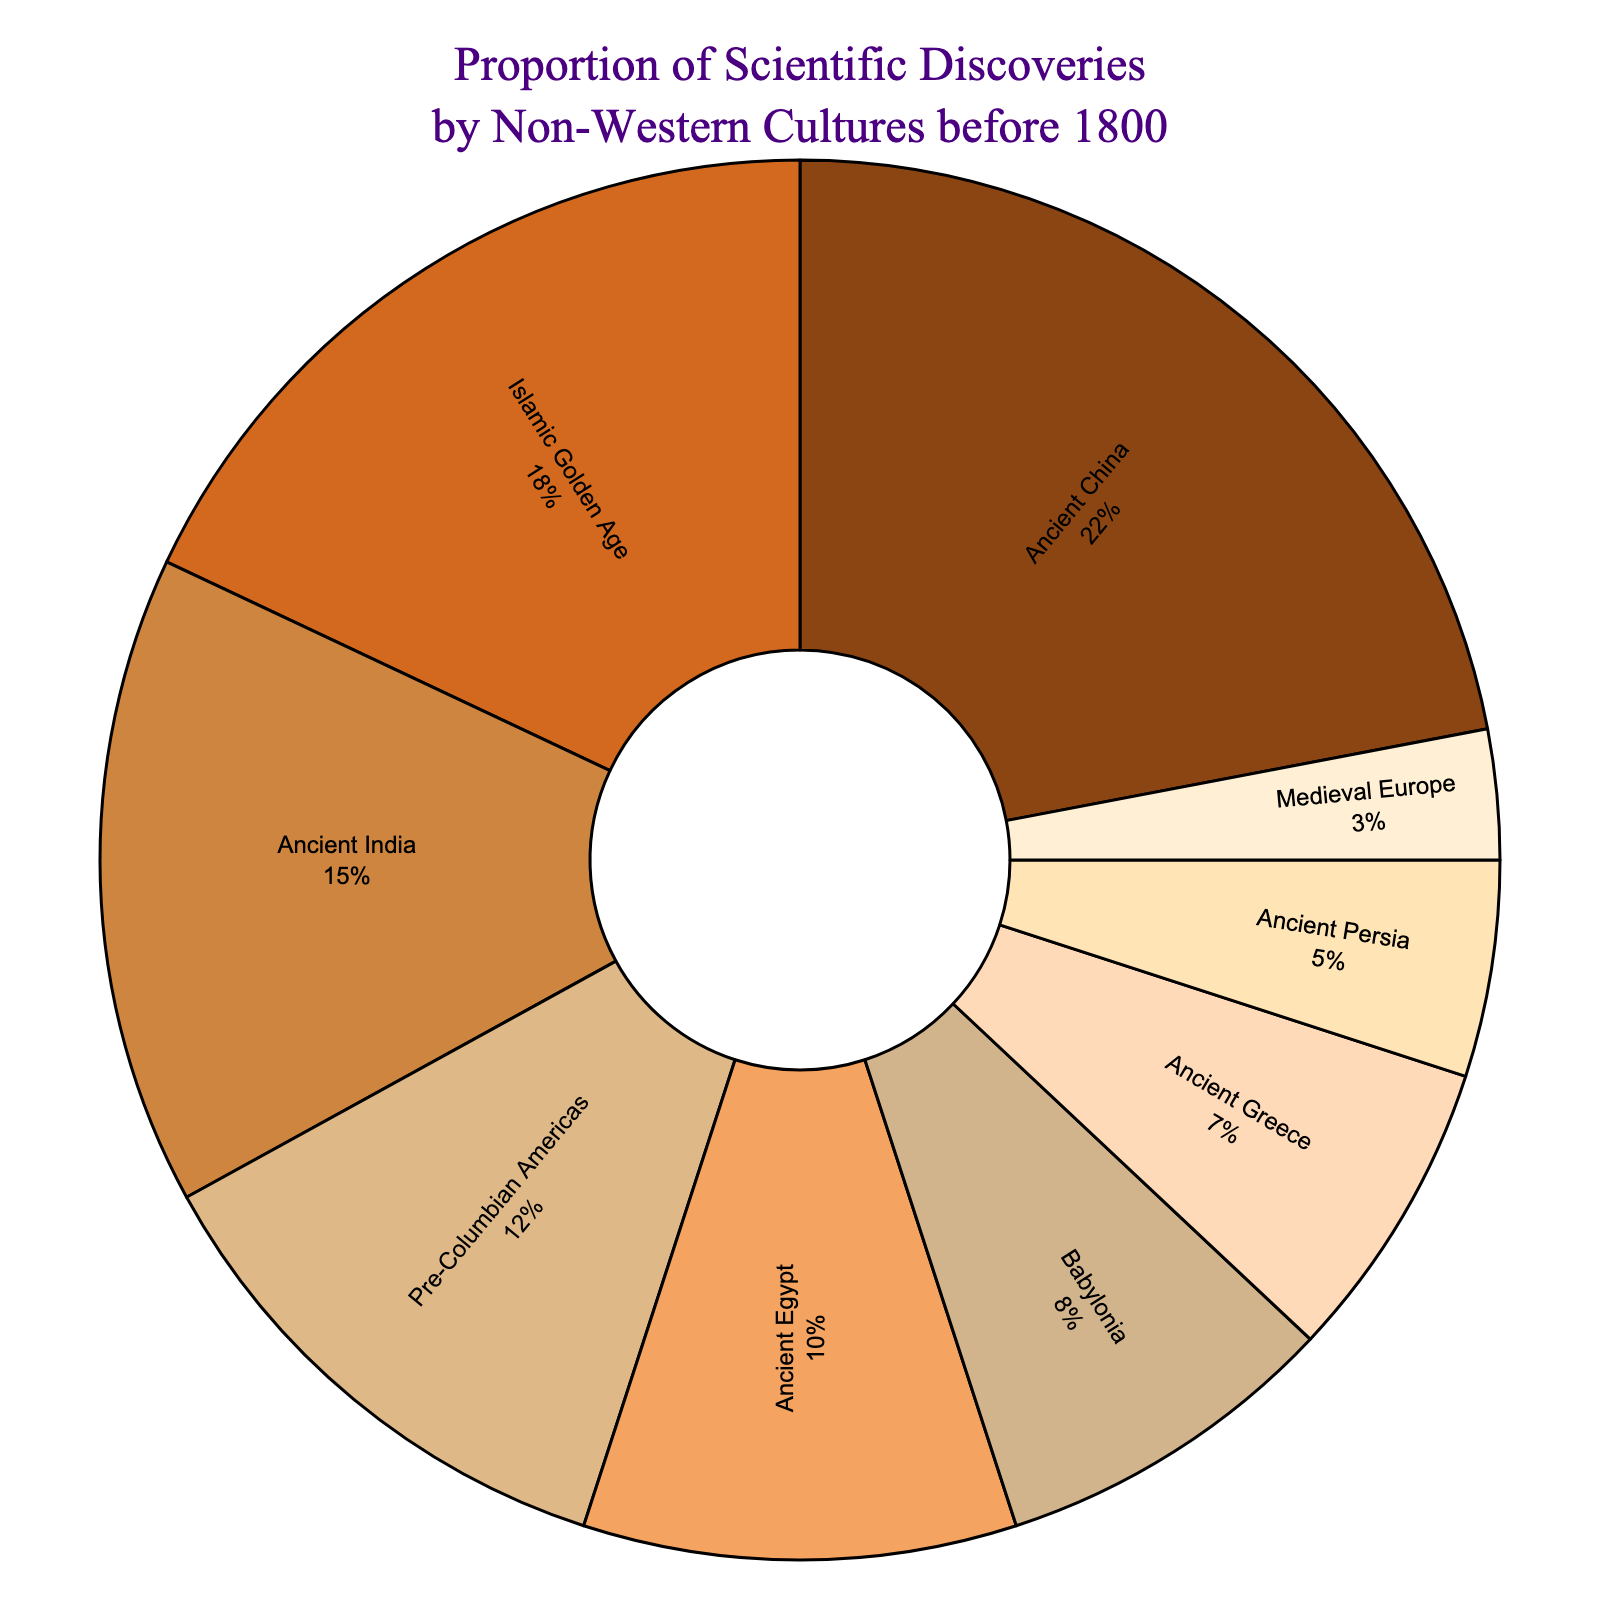What is the culture with the highest proportion of scientific discoveries? The culture with the highest proportion can be identified by locating the largest segment in the pie chart. The segment for Ancient China is the largest, indicating it has the highest proportion.
Answer: Ancient China What is the combined total percentage of scientific discoveries made by Ancient Greece and Ancient Persia? Sum the percentages of Ancient Greece and Ancient Persia. The percentage for Ancient Greece is 7% and for Ancient Persia is 5%. So, 7% + 5% = 12%.
Answer: 12% Which culture made more scientific discoveries: Islamic Golden Age or Ancient India? Compare the percentages for Islamic Golden Age and Ancient India. The percentage for Islamic Golden Age is 18%, and for Ancient India is 15%. Since 18% is greater than 15%, Islamic Golden Age made more discoveries.
Answer: Islamic Golden Age What is the difference in the proportion of scientific discoveries between Pre-Columbian Americas and Medieval Europe? Subtract the percentage of Medieval Europe from the percentage of Pre-Columbian Americas. The percentage for Pre-Columbian Americas is 12%, and for Medieval Europe is 3%. So, 12% - 3% = 9%.
Answer: 9% Which culture's segment is colored with the darkest brown shade? Visually identify the culture segment with the darkest brown color in the pie chart. The segment with the darkest brown corresponds to the label Ancient China.
Answer: Ancient China What is the total percentage of discoveries made by Ancient Egypt, Babylonia, and Ancient Persia combined? Sum the percentages for Ancient Egypt, Babylonia, and Ancient Persia. The percentage for Ancient Egypt is 10%, for Babylonia is 8%, and for Ancient Persia is 5%. So, 10% + 8% + 5% = 23%.
Answer: 23% Is the proportion of scientific discoveries made by Ancient India greater or less than twice the percentage of Medieval Europe? Compare twice the percentage of Medieval Europe to the percentage of Ancient India. Medieval Europe's percentage is 3%, so twice that is 3% * 2 = 6%. The percentage for Ancient India is 15%, which is greater than 6%.
Answer: Greater Which cultures collectively contribute more than half of the total scientific discoveries? Sum the percentages of the cultures and identify when the cumulative total exceeds 50%. Ancient China (22%), Islamic Golden Age (18%), and Ancient India (15%) together sum to 55%, which is more than half.
Answer: Ancient China, Islamic Golden Age, Ancient India What is the average percentage of scientific discoveries made by Ancient Egypt, Babylonia, and Ancient Persia? Calculate the average by summing the percentages and dividing by the number of cultures. The percentages are 10%, 8%, and 5%. The sum is 10% + 8% + 5% = 23%, and the average is 23% / 3 = 7.67%.
Answer: 7.67% Which two cultures have the smallest and the second smallest proportions of scientific discoveries, and what is their combined percentage? Identify the smallest and second smallest segments from the pie chart. Medieval Europe has the smallest percentage (3%) and Ancient Persia has the second smallest percentage (5%). Their combined percentage is 3% + 5% = 8%.
Answer: Medieval Europe, Ancient Persia, 8% 